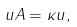Convert formula to latex. <formula><loc_0><loc_0><loc_500><loc_500>u A = \kappa u ,</formula> 